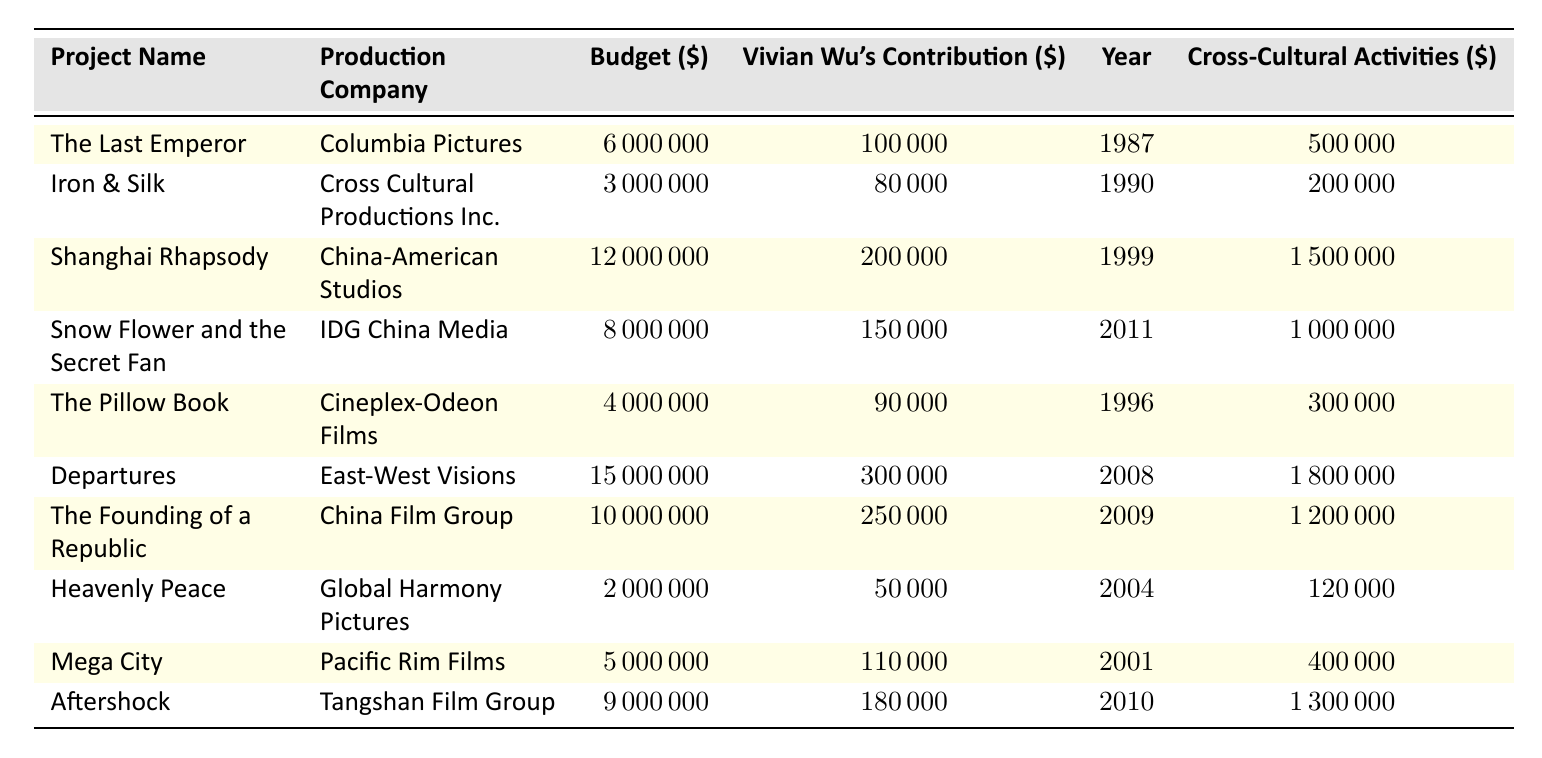What is the total budget allocated for the project "Departures"? The budget for "Departures" is explicitly listed in the table, which shows that it is 15,000,000.
Answer: 15000000 Which project has the highest contribution by Vivian Wu? By comparing the "Contribution By Vivian Wu" column, it's clear that "Departures" has the highest contribution at 300000.
Answer: 300000 What is the average budget of the projects listed in the table? There are 10 projects, and their budgets are 6000000, 3000000, 12000000, 8000000, 4000000, 15000000, 10000000, 2000000, 5000000, and 9000000. The total budget is 6000000 + 3000000 + 12000000 + 8000000 + 4000000 + 15000000 + 10000000 + 2000000 + 5000000 + 9000000 = 70000000, and the average is 70000000 / 10 = 7000000.
Answer: 7000000 Is the budget for "Heavenly Peace" less than 3 million dollars? The table lists the budget for "Heavenly Peace" as 2,000,000 dollars, which confirms that it is indeed less than 3 million.
Answer: Yes How much funding is allocated for cross-cultural activities across all projects in total? The allocations for cross-cultural activities are 500000, 200000, 1500000, 1000000, 300000, 1800000, 1200000, 120000, 400000, and 1300000. Adding these values results in a total of 500000 + 200000 + 1500000 + 1000000 + 300000 + 1800000 + 1200000 + 120000 + 400000 + 1300000 = 10400000.
Answer: 10400000 Which production company collaborated with Vivian Wu on the project "Snow Flower and the Secret Fan"? The table indicates that the production company for "Snow Flower and the Secret Fan" is "IDG China Media."
Answer: IDG China Media Was there any project with an allocated amount for cross-cultural activities lower than 300,000? By examining the "Allocated For Cross-Cultural Activities" column, "Heavenly Peace" has an amount of 120,000, which is lower than 300,000.
Answer: Yes What percentage of the total budget was allocated for cross-cultural activities for the project "Aftershock"? The budget for "Aftershock" is 9,000,000 and the allocation for cross-cultural activities is 1,300,000. The percentage is (1,300,000 / 9,000,000) * 100%, which results in approximately 14.44%.
Answer: 14.44% 